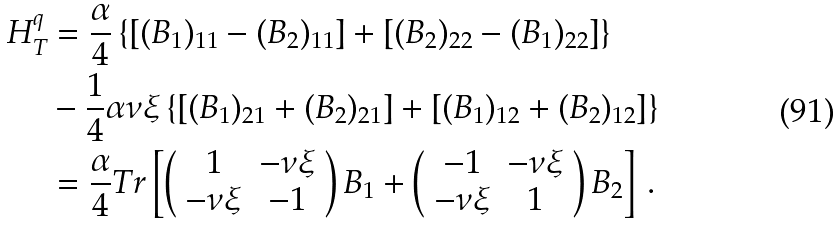Convert formula to latex. <formula><loc_0><loc_0><loc_500><loc_500>H _ { T } ^ { q } & = \frac { \alpha } { 4 } \left \{ \left [ ( B _ { 1 } ) _ { 1 1 } - ( B _ { 2 } ) _ { 1 1 } \right ] + \left [ ( B _ { 2 } ) _ { 2 2 } - ( B _ { 1 } ) _ { 2 2 } \right ] \right \} \\ & - \frac { 1 } { 4 } \alpha \nu \xi \left \{ \left [ ( B _ { 1 } ) _ { 2 1 } + ( B _ { 2 } ) _ { 2 1 } \right ] + \left [ ( B _ { 1 } ) _ { 1 2 } + ( B _ { 2 } ) _ { 1 2 } \right ] \right \} \\ & = \frac { \alpha } { 4 } T r \left [ \left ( \begin{array} [ c ] { c c } 1 & - \nu \xi \\ - \nu \xi & - 1 \end{array} \right ) B _ { 1 } + \left ( \begin{array} [ c ] { c c } - 1 & - \nu \xi \\ - \nu \xi & 1 \end{array} \right ) B _ { 2 } \right ] \, .</formula> 